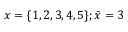<formula> <loc_0><loc_0><loc_500><loc_500>x = \{ 1 , 2 , 3 , 4 , 5 \} ; { \bar { x } } = 3</formula> 